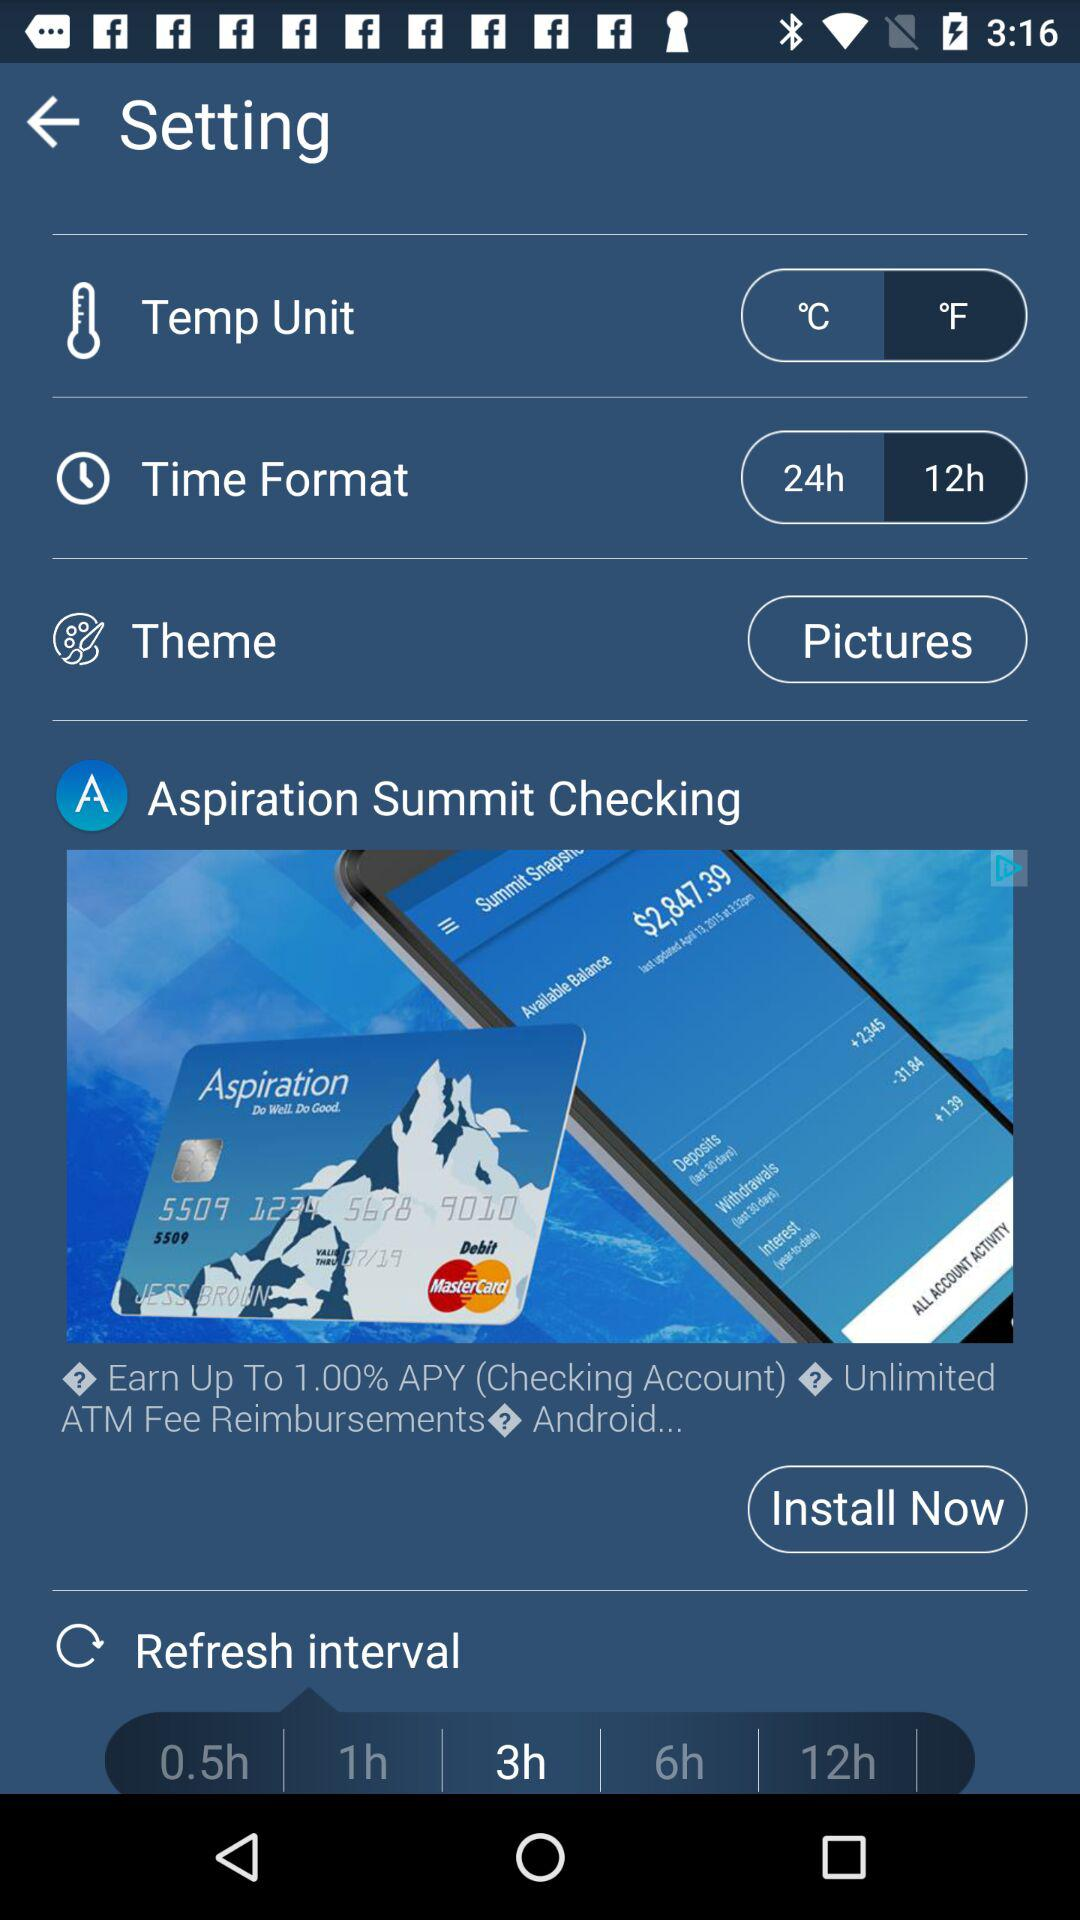What is the refresh interval? The refresh interval is every 3 hours. 